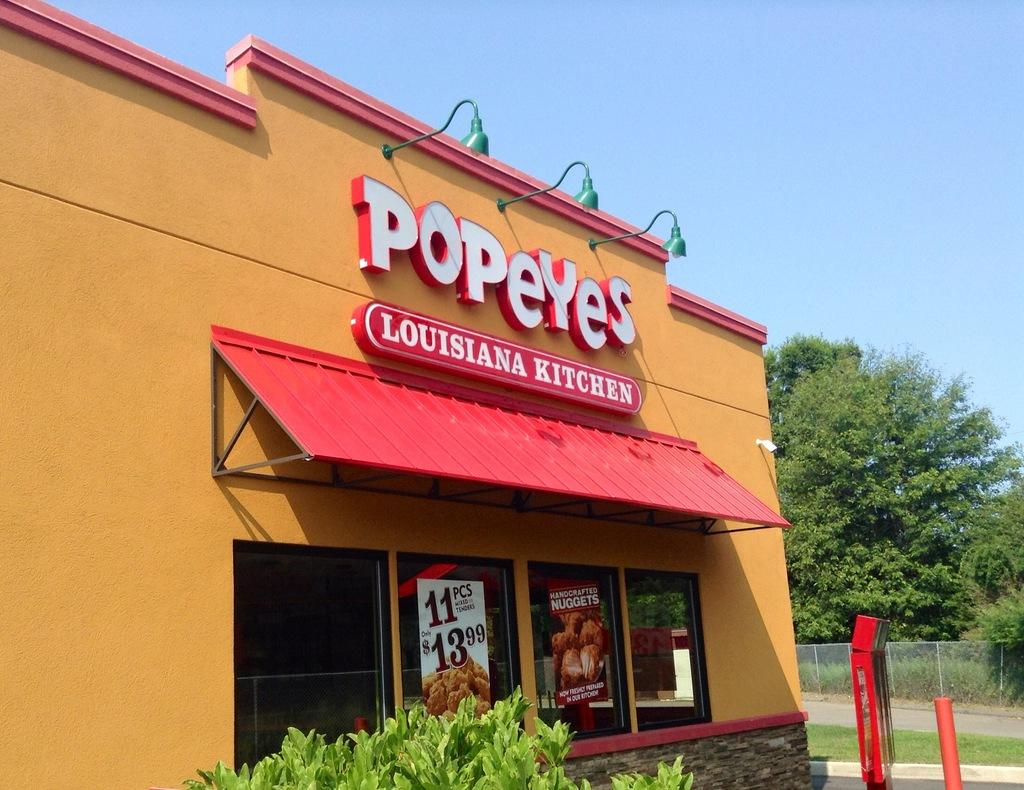What type of establishment is depicted in the image? There is a restaurant in the image. What can be seen illuminating the area in the image? There are lights in the image. What type of visual elements are present in the image? There are images in the image. What type of written information is present in the image? There is text in the image. What type of natural elements are present in the image? There are plants and trees in the image. What type of man-made structures are present in the image? There is a fence, a board, and a pole in the image. What can be seen in the background of the image? The sky is visible in the background of the image. How does the restaurant measure the speed of the wind in the image? There is no indication in the image that the restaurant is measuring the speed of the wind. 